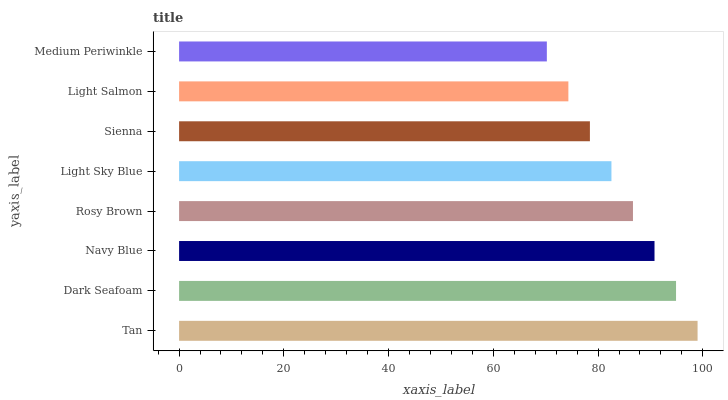Is Medium Periwinkle the minimum?
Answer yes or no. Yes. Is Tan the maximum?
Answer yes or no. Yes. Is Dark Seafoam the minimum?
Answer yes or no. No. Is Dark Seafoam the maximum?
Answer yes or no. No. Is Tan greater than Dark Seafoam?
Answer yes or no. Yes. Is Dark Seafoam less than Tan?
Answer yes or no. Yes. Is Dark Seafoam greater than Tan?
Answer yes or no. No. Is Tan less than Dark Seafoam?
Answer yes or no. No. Is Rosy Brown the high median?
Answer yes or no. Yes. Is Light Sky Blue the low median?
Answer yes or no. Yes. Is Navy Blue the high median?
Answer yes or no. No. Is Medium Periwinkle the low median?
Answer yes or no. No. 